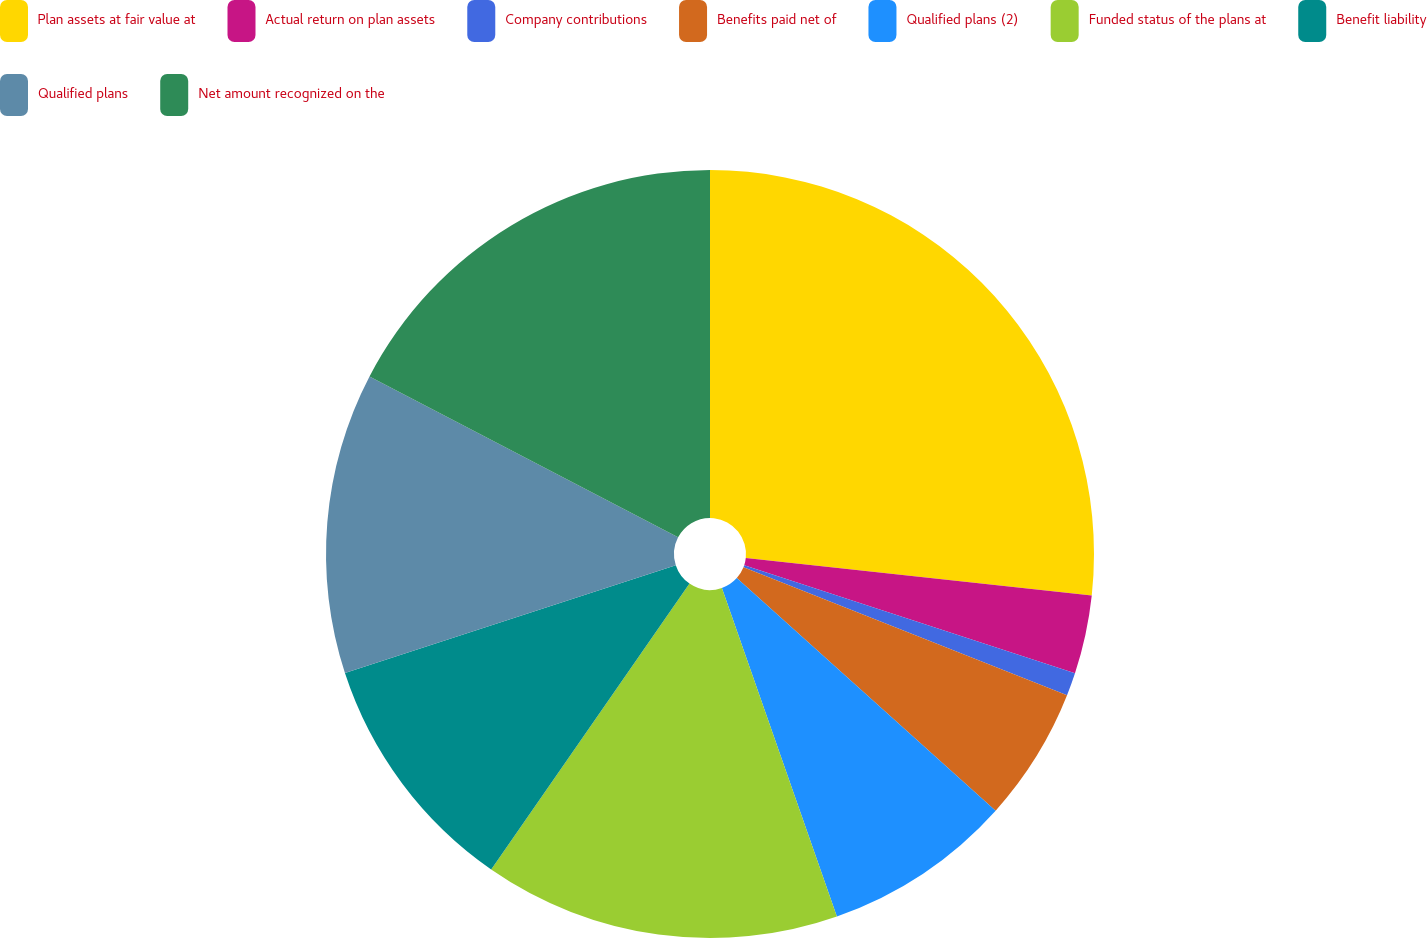<chart> <loc_0><loc_0><loc_500><loc_500><pie_chart><fcel>Plan assets at fair value at<fcel>Actual return on plan assets<fcel>Company contributions<fcel>Benefits paid net of<fcel>Qualified plans (2)<fcel>Funded status of the plans at<fcel>Benefit liability<fcel>Qualified plans<fcel>Net amount recognized on the<nl><fcel>26.72%<fcel>3.31%<fcel>0.97%<fcel>5.65%<fcel>7.99%<fcel>15.01%<fcel>10.33%<fcel>12.67%<fcel>17.35%<nl></chart> 